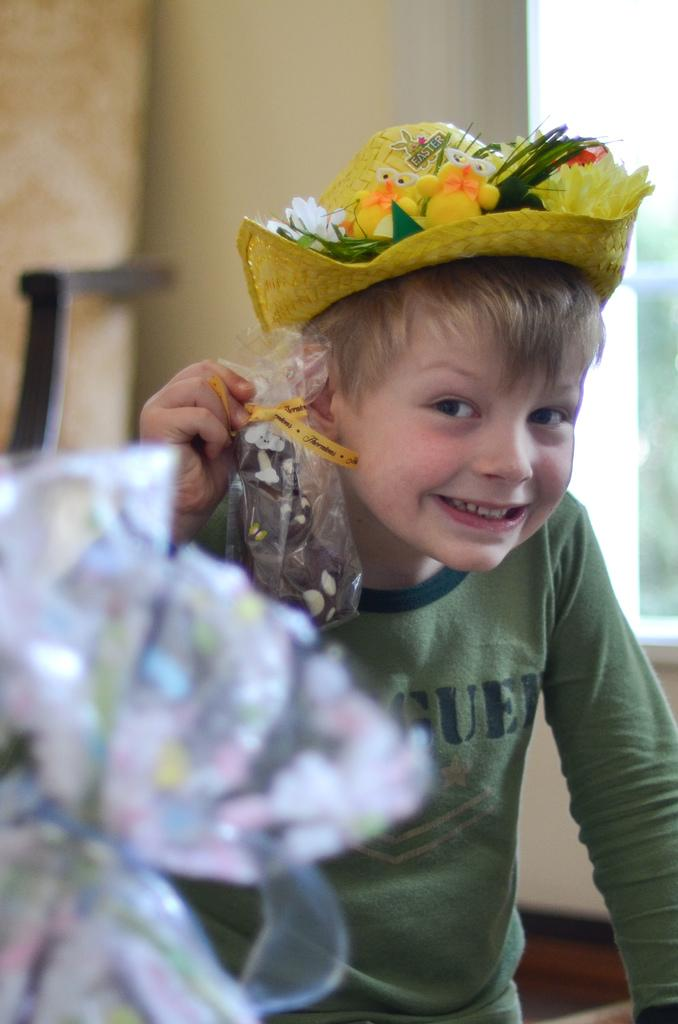What is the main subject of the image? The main subject of the image is a boy. What is the boy doing in the image? The boy is standing in the image. What is the boy holding in the image? The boy is holding chocolate in the image. Is the boy standing on quicksand in the image? There is no indication of quicksand in the image; the boy is simply standing. What direction is the boy facing in the image? The provided facts do not specify the direction the boy is facing in the image. 